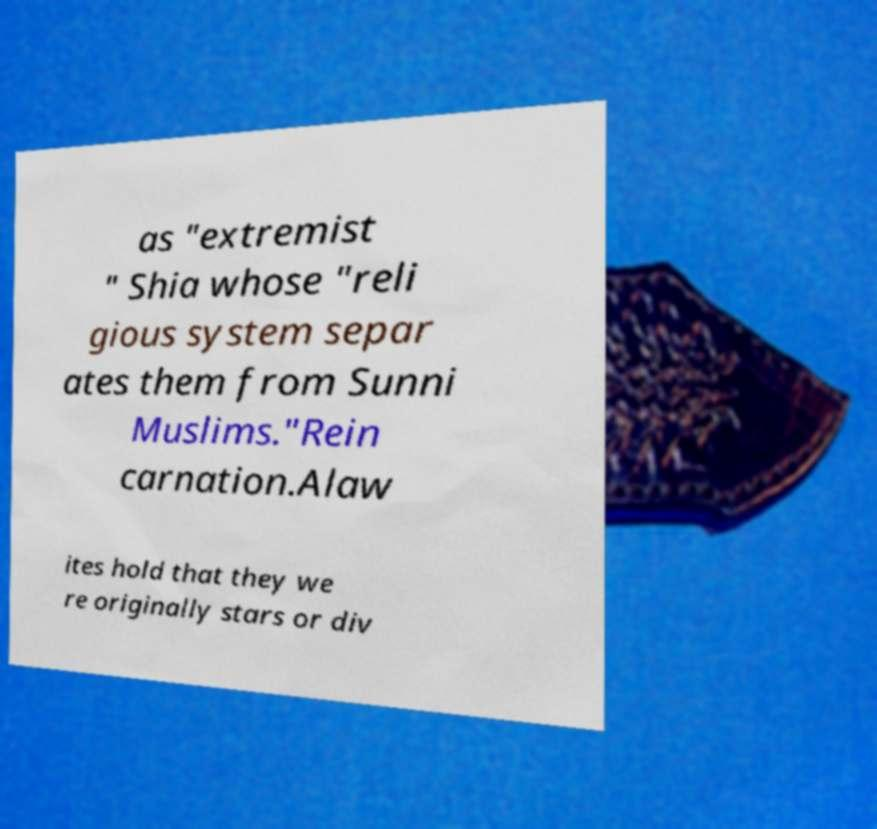Could you assist in decoding the text presented in this image and type it out clearly? as "extremist " Shia whose "reli gious system separ ates them from Sunni Muslims."Rein carnation.Alaw ites hold that they we re originally stars or div 